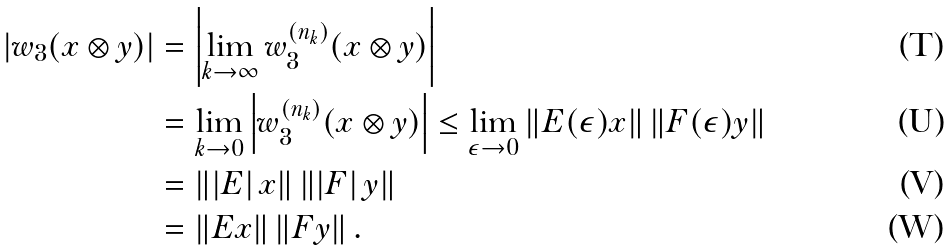Convert formula to latex. <formula><loc_0><loc_0><loc_500><loc_500>\left | w _ { 3 } ( x \otimes y ) \right | & = \left | \lim _ { k \rightarrow \infty } w ^ { ( n _ { k } ) } _ { 3 } ( x \otimes y ) \right | \\ & = \lim _ { k \rightarrow 0 } \left | w ^ { ( n _ { k } ) } _ { 3 } ( x \otimes y ) \right | \leq \lim _ { \epsilon \rightarrow 0 } \left \| E ( \epsilon ) x \right \| \left \| F ( \epsilon ) y \right \| \\ & = \left \| \left | E \right | x \right \| \left \| \left | F \right | y \right \| \\ & = \left \| E x \right \| \left \| F y \right \| .</formula> 